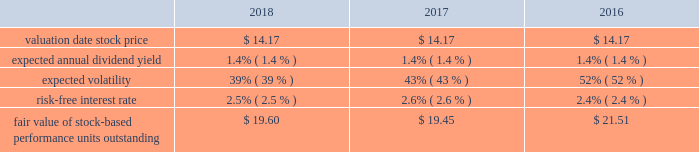Marathon oil corporation notes to consolidated financial statements stock-based performance unit awards 2013 during 2018 , 2017 and 2016 we granted 754140 , 563631 and 1205517 stock- based performance unit awards to officers .
At december 31 , 2018 , there were 1196176 units outstanding .
Total stock-based performance unit awards expense was $ 13 million in 2018 , $ 8 million in 2017 and $ 6 million in 2016 .
The key assumptions used in the monte carlo simulation to determine the fair value of stock-based performance units granted in 2018 , 2017 and 2016 were: .
18 .
Defined benefit postretirement plans and defined contribution plan we have noncontributory defined benefit pension plans covering substantially all domestic employees , as well as u.k .
Employees who were hired before april 2010 .
Certain employees located in e.g. , who are u.s .
Or u.k .
Based , also participate in these plans .
Benefits under these plans are based on plan provisions specific to each plan .
For the u.k .
Pension plan , the principal employer and plan trustees reached a decision to close the plan to future benefit accruals effective december 31 , 2015 .
We also have defined benefit plans for other postretirement benefits covering our u.s .
Employees .
Health care benefits are provided up to age 65 through comprehensive hospital , surgical and major medical benefit provisions subject to various cost- sharing features .
Post-age 65 health care benefits are provided to certain u.s .
Employees on a defined contribution basis .
Life insurance benefits are provided to certain retiree beneficiaries .
These other postretirement benefits are not funded in advance .
Employees hired after 2016 are not eligible for any postretirement health care or life insurance benefits. .
What was total stock-based performance unit awards expense in 2018 , 2017 , and 2016 , in millions? 
Computations: ((13 + 8) + 6)
Answer: 27.0. 